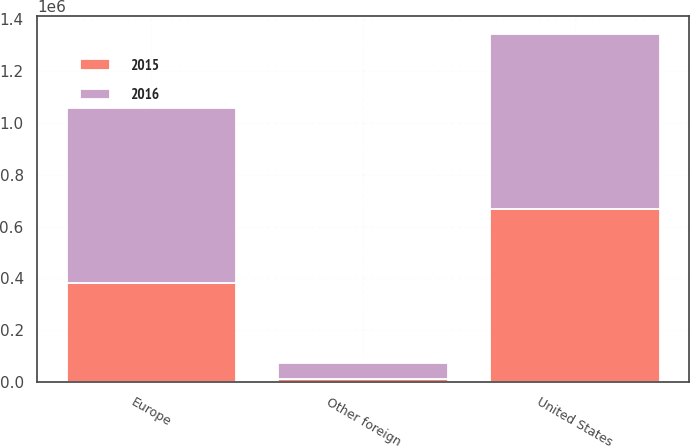<chart> <loc_0><loc_0><loc_500><loc_500><stacked_bar_chart><ecel><fcel>United States<fcel>Europe<fcel>Other foreign<nl><fcel>2016<fcel>676007<fcel>673767<fcel>60032<nl><fcel>2015<fcel>666759<fcel>383501<fcel>13197<nl></chart> 